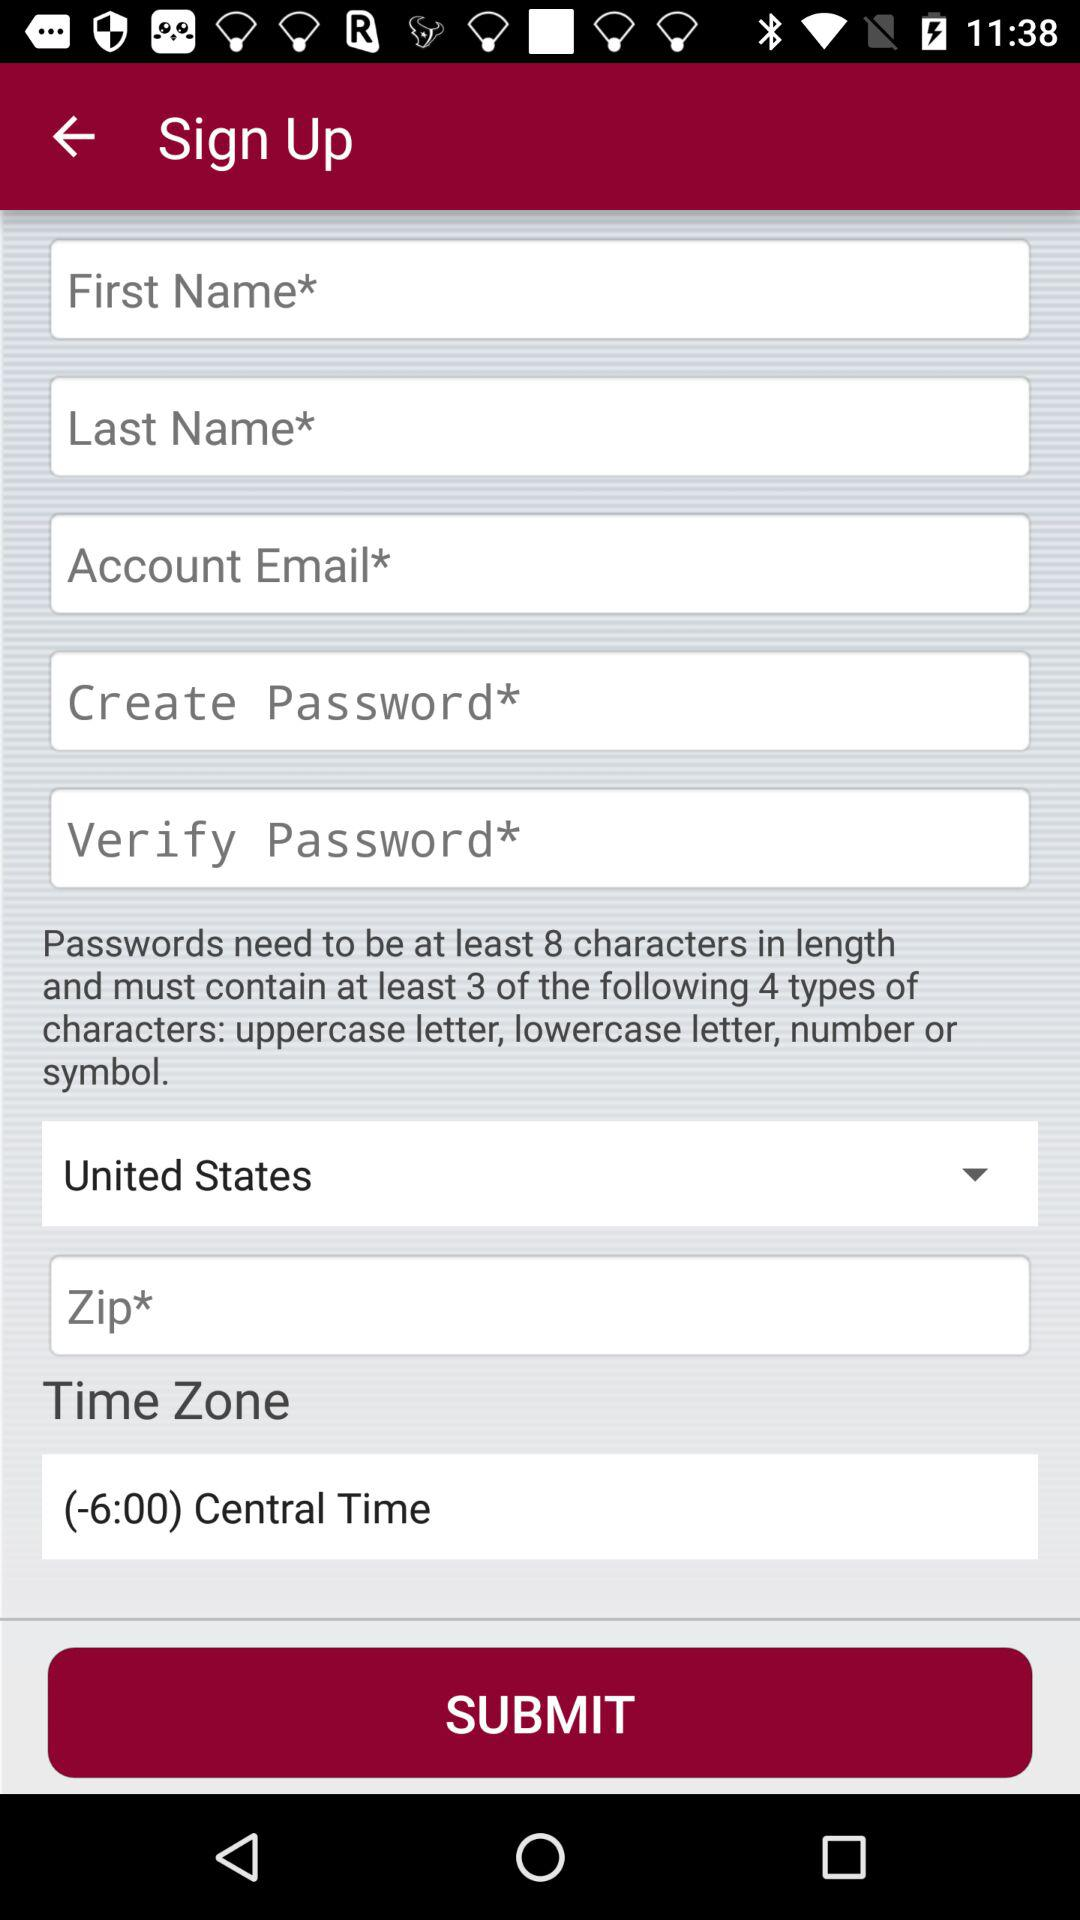What is the mentioned time zone? The mentioned time zone is (-6:00) Central Time. 